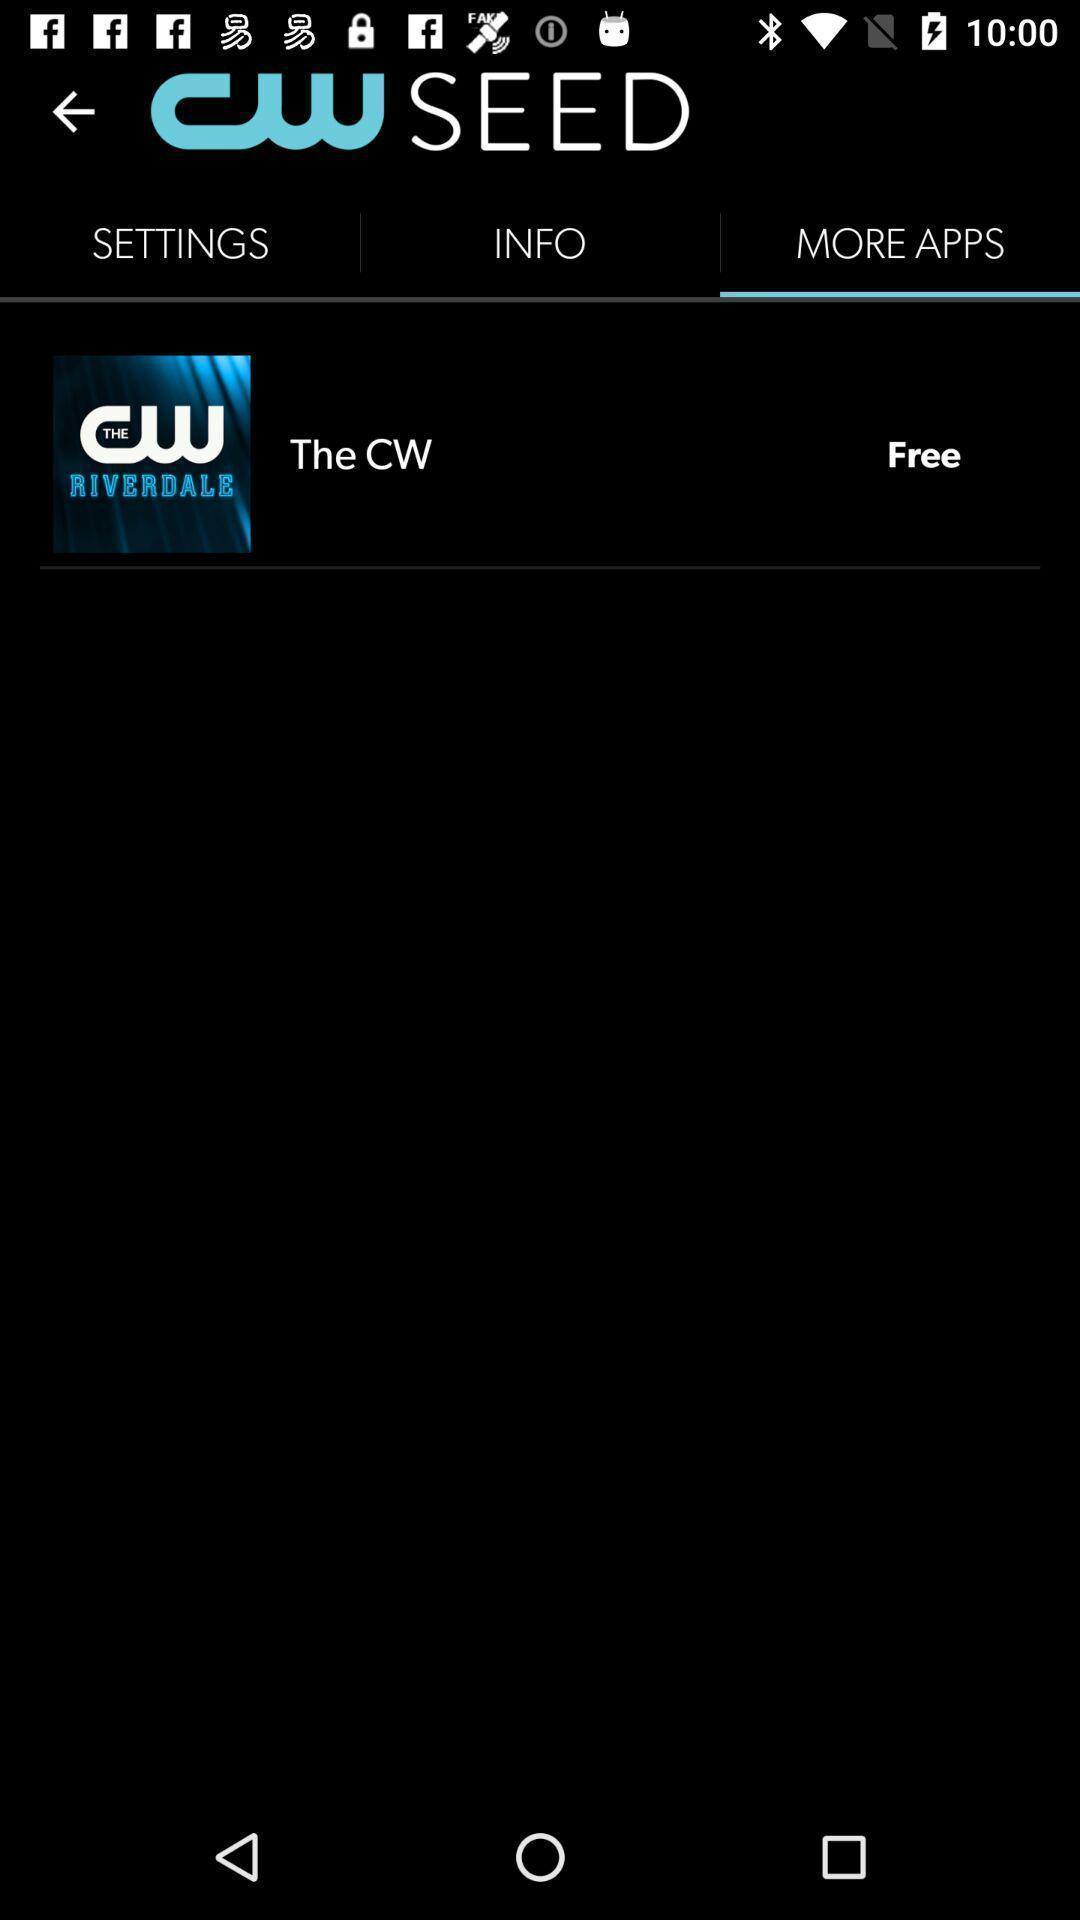Describe the visual elements of this screenshot. Screen displaying the app option which is free. 